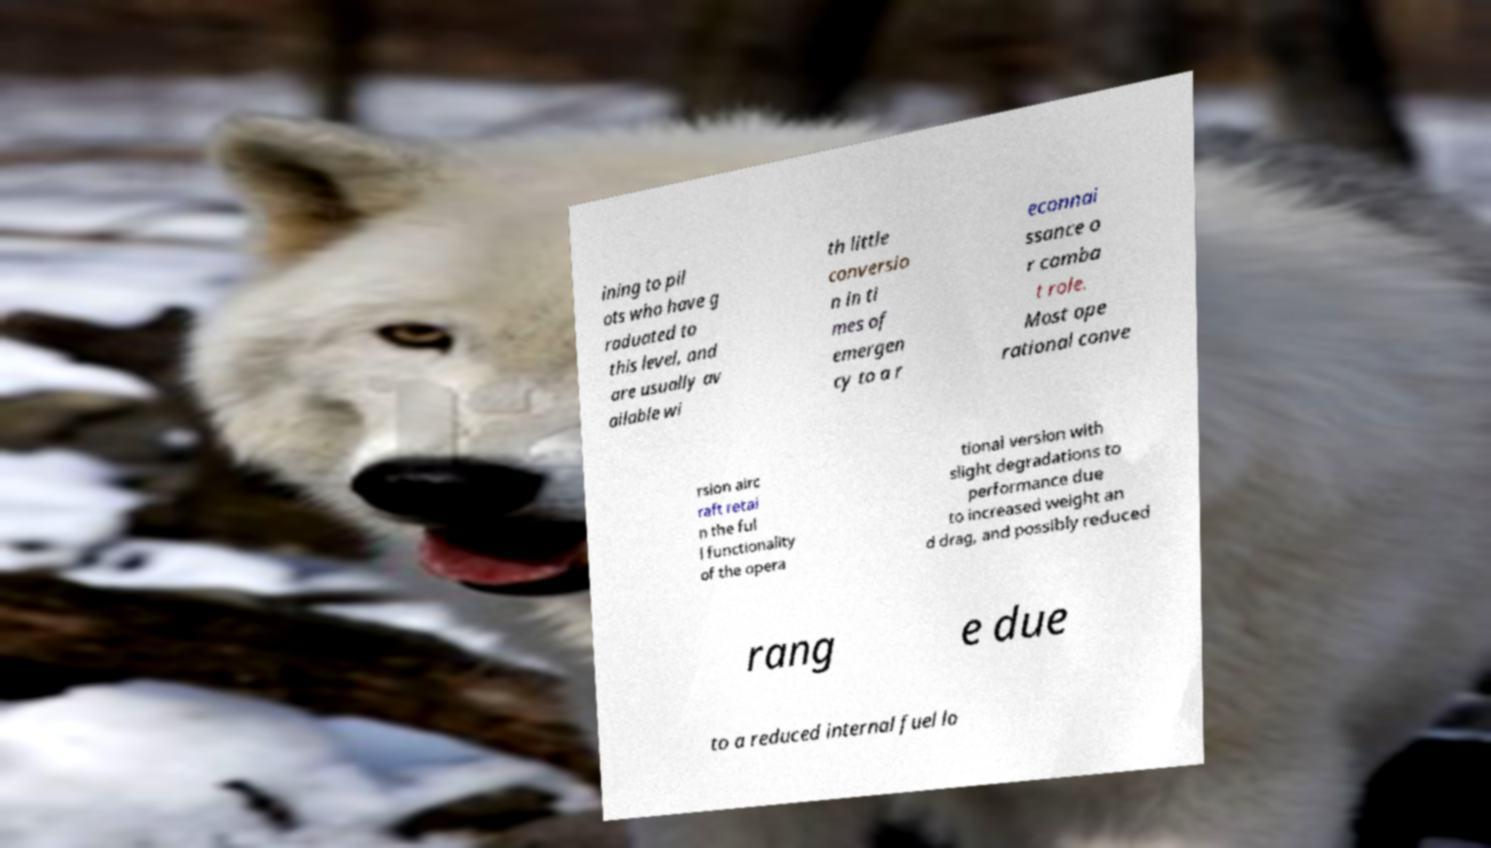Can you read and provide the text displayed in the image?This photo seems to have some interesting text. Can you extract and type it out for me? ining to pil ots who have g raduated to this level, and are usually av ailable wi th little conversio n in ti mes of emergen cy to a r econnai ssance o r comba t role. Most ope rational conve rsion airc raft retai n the ful l functionality of the opera tional version with slight degradations to performance due to increased weight an d drag, and possibly reduced rang e due to a reduced internal fuel lo 